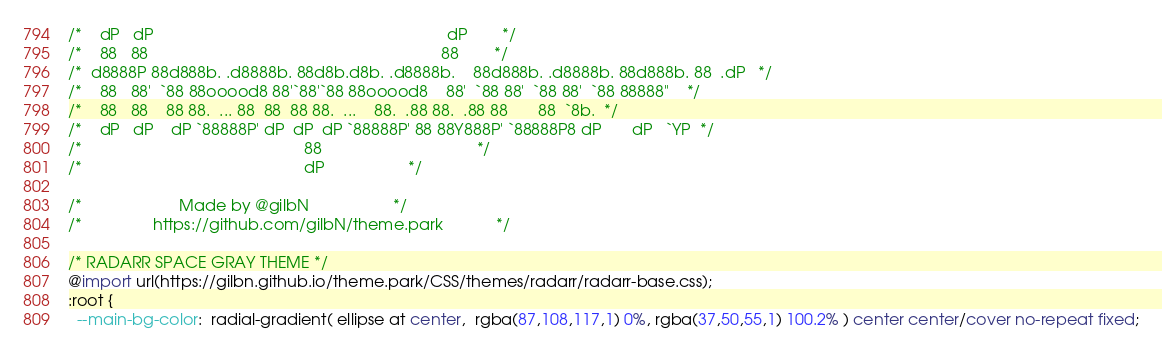<code> <loc_0><loc_0><loc_500><loc_500><_CSS_>
/*    dP   dP                                                                  dP        */
/*    88   88                                                                  88        */
/*  d8888P 88d888b. .d8888b. 88d8b.d8b. .d8888b.    88d888b. .d8888b. 88d888b. 88  .dP   */
/*    88   88'  `88 88ooood8 88'`88'`88 88ooood8    88'  `88 88'  `88 88'  `88 88888"    */
/*    88   88    88 88.  ... 88  88  88 88.  ...    88.  .88 88.  .88 88       88  `8b.  */
/*    dP   dP    dP `88888P' dP  dP  dP `88888P' 88 88Y888P' `88888P8 dP       dP   `YP  */
/*                                                  88                                   */
/*                                                  dP					 */

/*		   		        Made by @gilbN					 */
/*			      https://github.com/gilbN/theme.park			 */

/* RADARR SPACE GRAY THEME */
@import url(https://gilbn.github.io/theme.park/CSS/themes/radarr/radarr-base.css);
:root {
  --main-bg-color:  radial-gradient( ellipse at center,  rgba(87,108,117,1) 0%, rgba(37,50,55,1) 100.2% ) center center/cover no-repeat fixed;</code> 